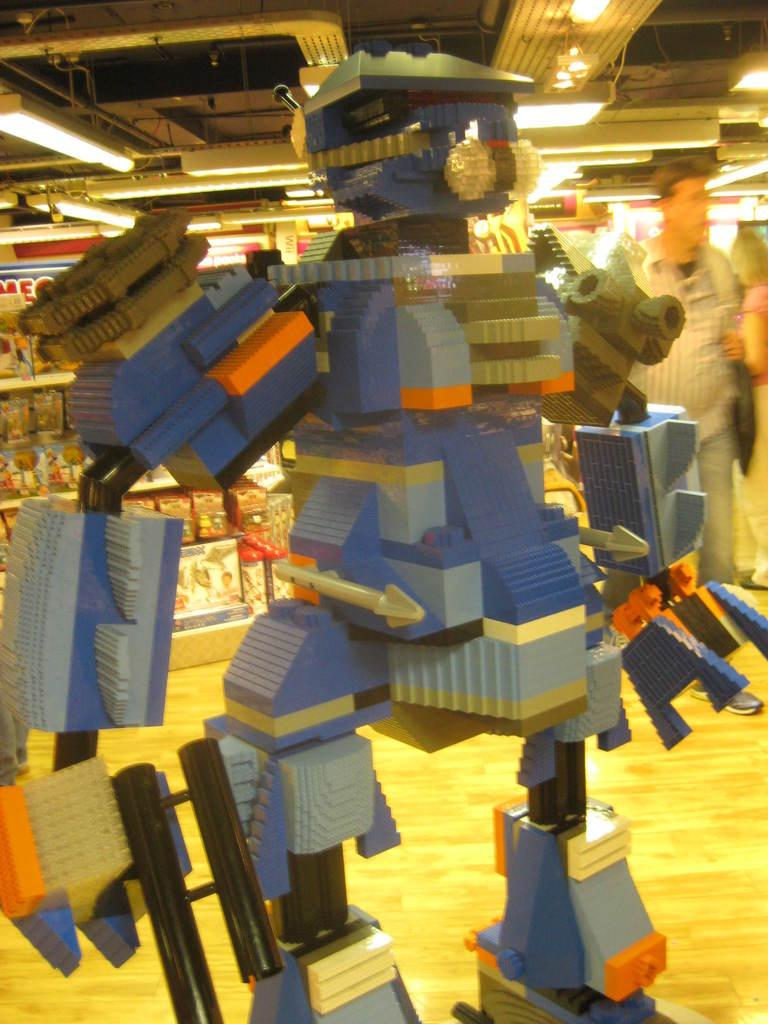What is the main subject in the foreground of the image? There is a Lego toy in the foreground of the image. Where are the people located in the image? The people are on the right side of the image. What can be seen in the background of the image? There are toys on a rack shelf in the background of the image. What is present at the top of the image? There are light arrangements at the top of the image. Can you tell me how many nests are visible in the image? There are no nests present in the image. What type of sport is being played by the men in the image? There are no men or any indication of a sport being played in the image. 